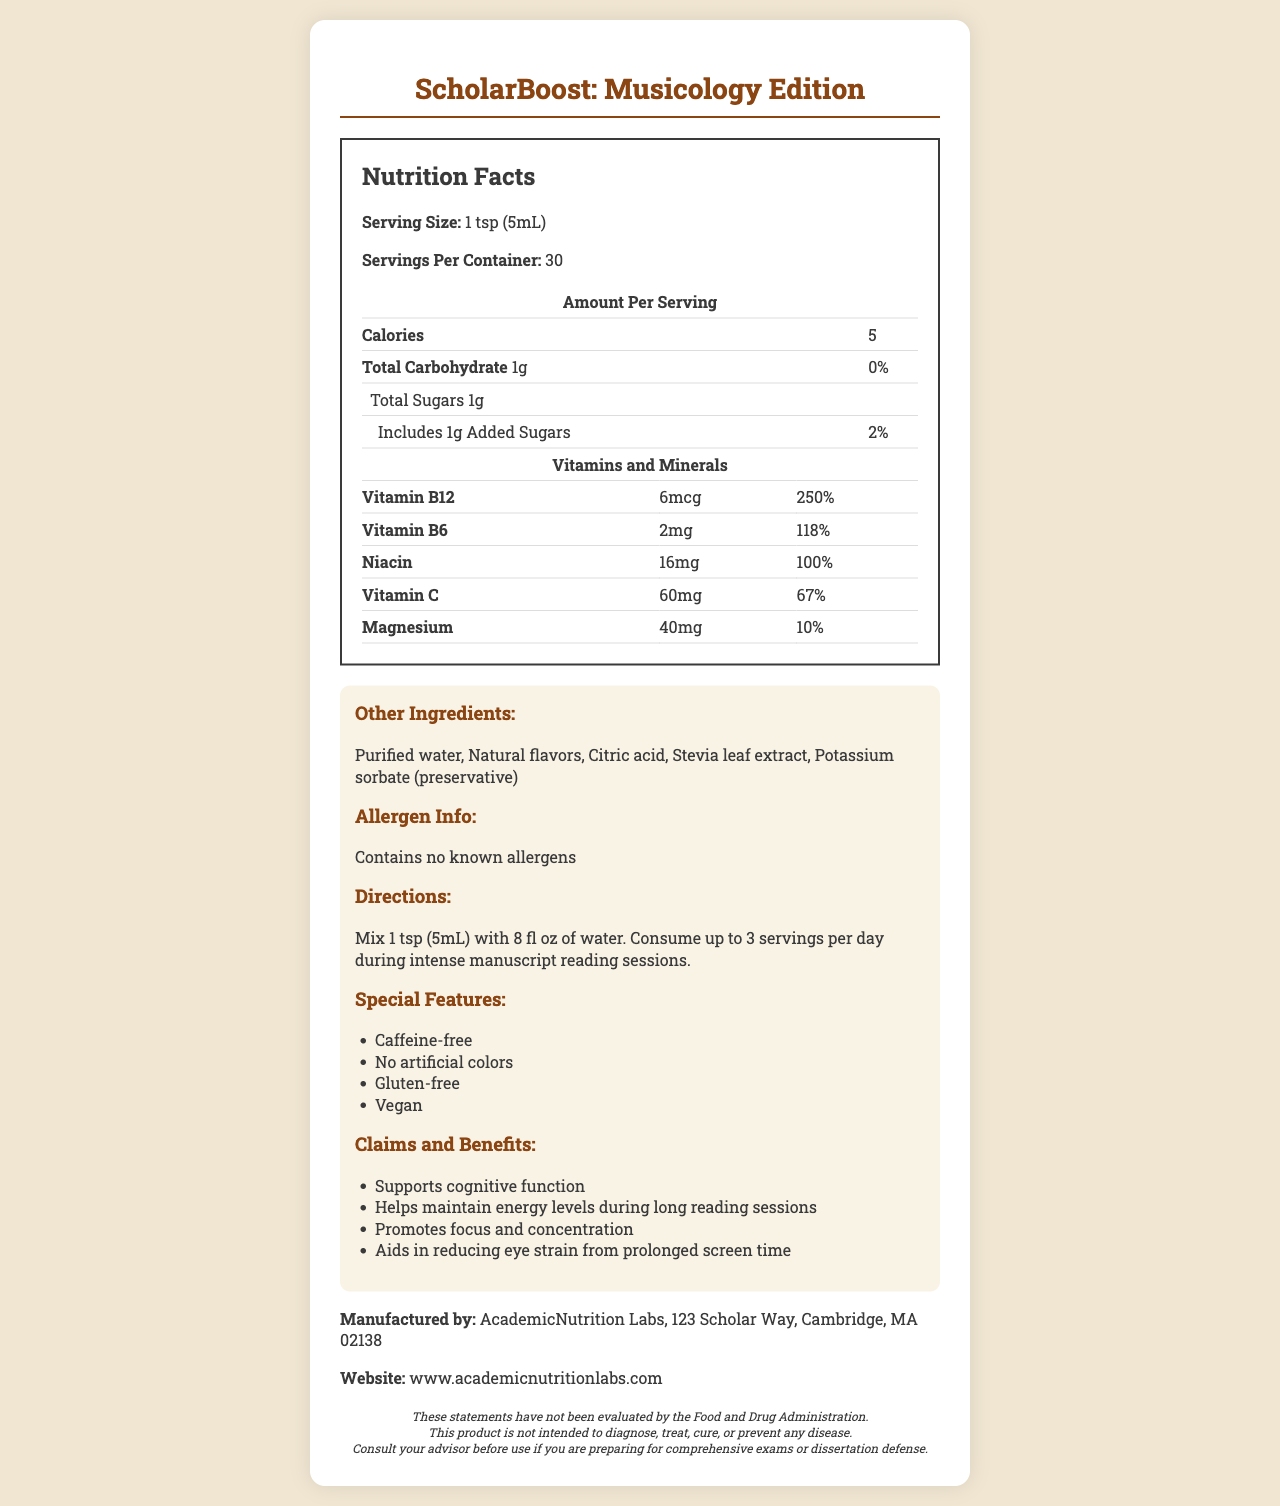what is the serving size? The serving size is clearly listed as “1 tsp (5mL)” in the nutrition facts section.
Answer: 1 tsp (5mL) how many calories are there per serving? The nutrition label mentions that each serving contains 5 calories.
Answer: 5 which vitamin has the highest daily value percentage? The daily value for Vitamin B12 is listed as 250%, which is the highest among the vitamins and minerals provided.
Answer: Vitamin B12 how many servings per container are there? The document states that there are 30 servings per container.
Answer: 30 what is the amount of Vitamin C per serving? The amount of Vitamin C per serving is shown as 60mg with a daily value of 67%.
Answer: 60mg what is the total carbohydrate content per serving? A. 1g B. 2g C. 5g The nutrition label lists the total carbohydrate content per serving as 1g.
Answer: A how much sugar is added in each serving? A. 0g B. 1g C. 2g D. 5g The document shows that 1g of added sugar is included in each serving.
Answer: B is ScholarBoost gluten-free? Under the special features, it is mentioned that the product is gluten-free.
Answer: Yes what is the main purpose of this vitamin-fortified water enhancer? The claims and benefits section states that the product supports cognitive function, helps maintain energy levels during long reading sessions, promotes focus and concentration, and aids in reducing eye strain from prolonged screen time.
Answer: Provides cognitive and energy support during intense manuscript reading where is the manufacturer located? The manufacturer's address is provided in the manufacturer information section.
Answer: 123 Scholar Way, Cambridge, MA 02138 what are the main ingredients other than vitamins and minerals? These ingredients are listed in the other ingredients section.
Answer: Purified water, Natural flavors, Citric acid, Stevia leaf extract, Potassium sorbate (preservative) what is the recommended daily limit for consuming this product? The directions recommend consuming up to 3 servings per day during intense manuscript reading sessions.
Answer: Up to 3 servings does the product contain any known allergens? The allergen information section states that the product contains no known allergens.
Answer: No can this product diagnose or treat diseases? The disclaimers mention that the product is not intended to diagnose, treat, cure, or prevent any disease.
Answer: No what vitamin does not have its daily value percentage listed? All vitamins listed in the document have their daily value percentage mentioned.
Answer: Not applicable how is the product intended to be consumed? The directions specify to mix 1 tsp (5mL) with 8 fl oz of water.
Answer: Mix 1 tsp (5mL) with 8 fl oz of water does the product contain caffeine? The special features indicate that the product is caffeine-free.
Answer: No how much Magnesium is provided per serving? The amount of magnesium per serving is listed as 40 mg with a daily value of 10%.
Answer: 40mg which vitamin has a daily value of 100%? The label indicates that Niacin has a daily value of 100%.
Answer: Niacin summary of the document The document provides comprehensive nutrition facts and product details for the ScholarBoost water enhancer, emphasizing its benefits for cognitive function and energy support during extended periods of reading and study.
Answer: The document is an in-depth Nutrition Facts Label for "ScholarBoost: Musicology Edition," a vitamin-fortified water enhancer designed to combat fatigue during intense manuscript reading sessions. It outlines the servings per container, calories, and detailed vitamin and mineral contents. It also describes the product’s claims, special features such as being caffeine-free and gluten-free, ingredients, allergen information, directions for use, and manufacturer details. Additionally, it includes important disclaimers about its use and purpose. 